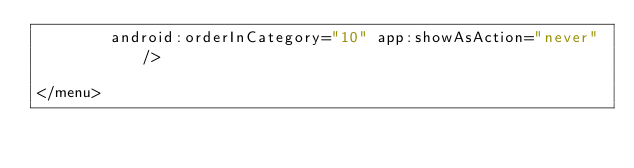Convert code to text. <code><loc_0><loc_0><loc_500><loc_500><_XML_>        android:orderInCategory="10" app:showAsAction="never" />

</menu></code> 